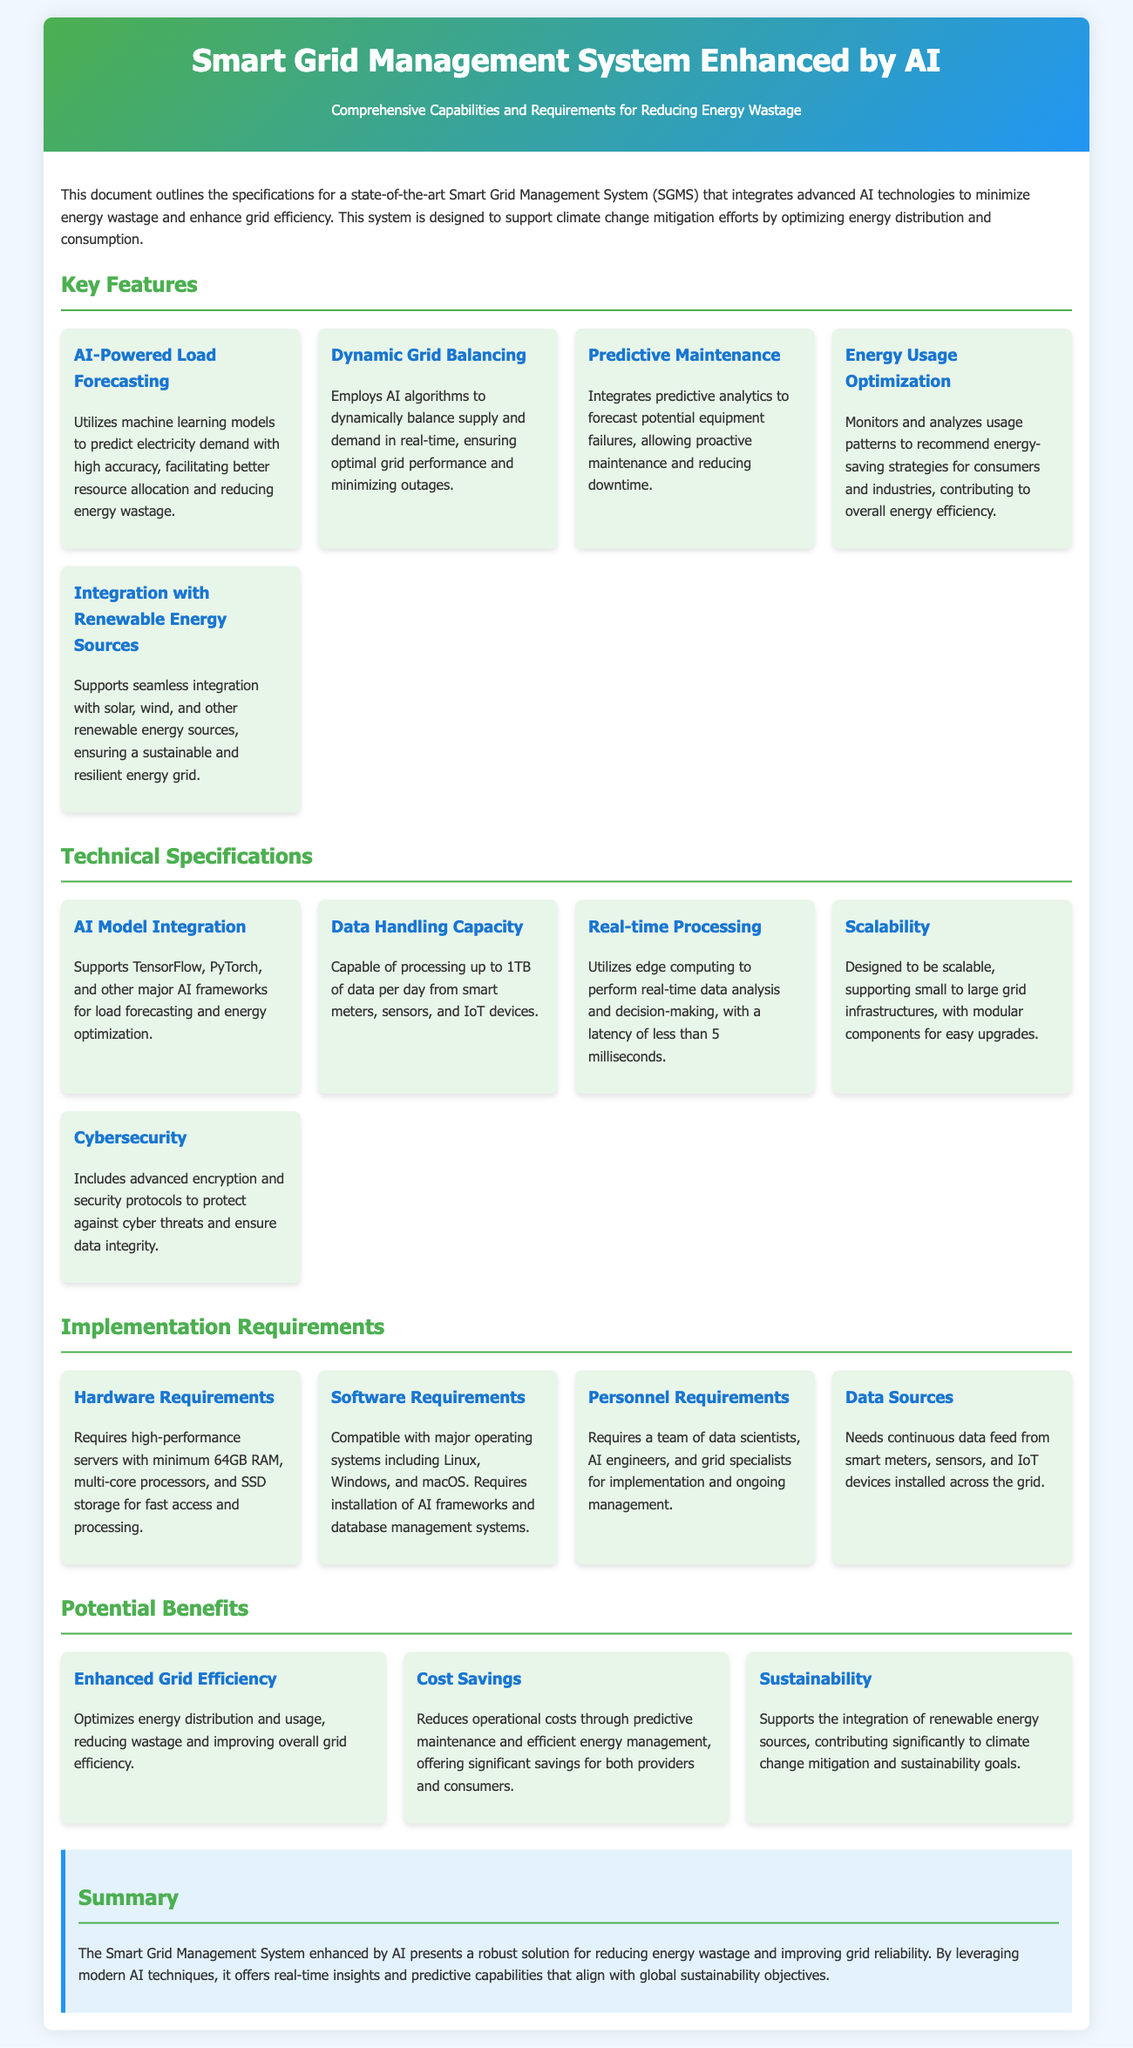What is the purpose of the Smart Grid Management System? The purpose is to minimize energy wastage and enhance grid efficiency to support climate change mitigation efforts.
Answer: Minimize energy wastage How many key features are listed in the document? The document outlines five key features of the Smart Grid Management System.
Answer: Five What is the AI model integration compatibility? The system supports TensorFlow, PyTorch, and other major AI frameworks.
Answer: TensorFlow, PyTorch What is the real-time data processing latency? The system is capable of processing data with a latency of less than 5 milliseconds.
Answer: Less than 5 milliseconds What type of personnel is required for implementation? A team of data scientists, AI engineers, and grid specialists is required.
Answer: Data scientists, AI engineers, grid specialists How much data can the system process per day? The system is capable of processing up to 1TB of data per day.
Answer: Up to 1TB What is a potential benefit of the Smart Grid Management System? One potential benefit is the optimization of energy distribution and usage.
Answer: Enhanced Grid Efficiency What kind of energy sources does the system integrate with? The system integrates with solar, wind, and other renewable energy sources.
Answer: Solar, wind, renewable energy sources 